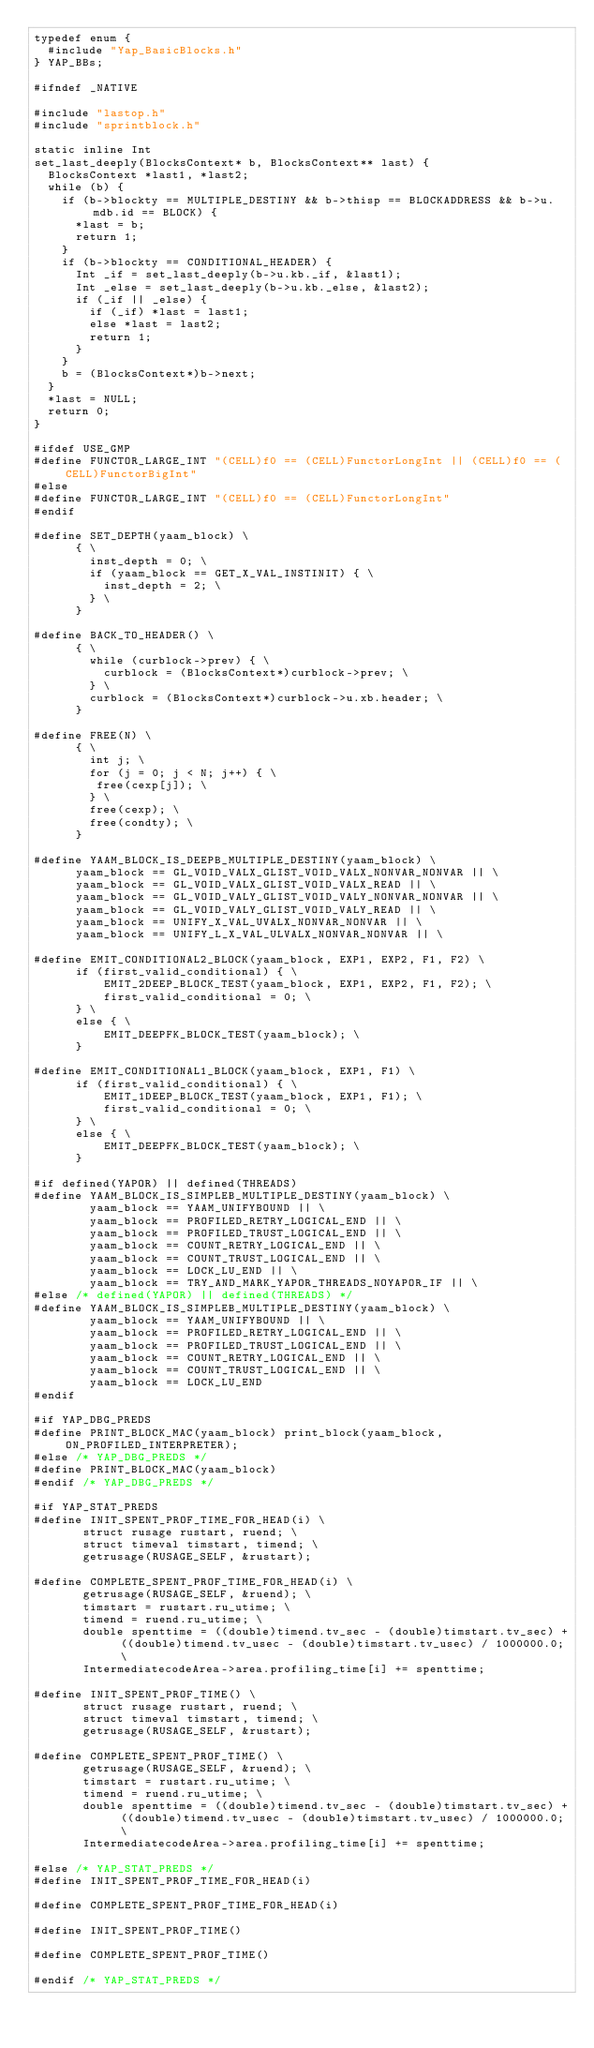<code> <loc_0><loc_0><loc_500><loc_500><_C++_>typedef enum {
  #include "Yap_BasicBlocks.h"
} YAP_BBs;

#ifndef _NATIVE

#include "lastop.h"
#include "sprintblock.h"

static inline Int
set_last_deeply(BlocksContext* b, BlocksContext** last) {
  BlocksContext *last1, *last2;
  while (b) {
    if (b->blockty == MULTIPLE_DESTINY && b->thisp == BLOCKADDRESS && b->u.mdb.id == BLOCK) {
      *last = b;
      return 1;
    }
    if (b->blockty == CONDITIONAL_HEADER) {
	  Int _if = set_last_deeply(b->u.kb._if, &last1);
	  Int _else = set_last_deeply(b->u.kb._else, &last2);
      if (_if || _else) {
		if (_if) *last = last1;
		else *last = last2;
	    return 1;
	  }
    }
    b = (BlocksContext*)b->next;
  }
  *last = NULL;
  return 0;
}

#ifdef USE_GMP
#define FUNCTOR_LARGE_INT "(CELL)f0 == (CELL)FunctorLongInt || (CELL)f0 == (CELL)FunctorBigInt"
#else
#define FUNCTOR_LARGE_INT "(CELL)f0 == (CELL)FunctorLongInt"
#endif

#define SET_DEPTH(yaam_block) \
      { \
	    inst_depth = 0; \
	    if (yaam_block == GET_X_VAL_INSTINIT) { \
	      inst_depth = 2; \
		} \
	  }

#define BACK_TO_HEADER() \
      { \
        while (curblock->prev) { \
          curblock = (BlocksContext*)curblock->prev; \
        } \
        curblock = (BlocksContext*)curblock->u.xb.header; \
      }
      
#define FREE(N) \
      { \
		int j; \
		for (j = 0; j < N; j++) { \
		 free(cexp[j]); \
		} \
		free(cexp); \
		free(condty); \
	  }

#define YAAM_BLOCK_IS_DEEPB_MULTIPLE_DESTINY(yaam_block) \
	  yaam_block == GL_VOID_VALX_GLIST_VOID_VALX_NONVAR_NONVAR || \
	  yaam_block == GL_VOID_VALX_GLIST_VOID_VALX_READ || \
	  yaam_block == GL_VOID_VALY_GLIST_VOID_VALY_NONVAR_NONVAR || \
	  yaam_block == GL_VOID_VALY_GLIST_VOID_VALY_READ || \
	  yaam_block == UNIFY_X_VAL_UVALX_NONVAR_NONVAR || \
	  yaam_block == UNIFY_L_X_VAL_ULVALX_NONVAR_NONVAR || \
	  
#define EMIT_CONDITIONAL2_BLOCK(yaam_block, EXP1, EXP2, F1, F2) \
	  if (first_valid_conditional) { \
	      EMIT_2DEEP_BLOCK_TEST(yaam_block, EXP1, EXP2, F1, F2); \
	      first_valid_conditional = 0; \
	  } \
	  else { \
	      EMIT_DEEPFK_BLOCK_TEST(yaam_block); \
	  }
	  
#define EMIT_CONDITIONAL1_BLOCK(yaam_block, EXP1, F1) \
	  if (first_valid_conditional) { \
	      EMIT_1DEEP_BLOCK_TEST(yaam_block, EXP1, F1); \
	      first_valid_conditional = 0; \
	  } \
	  else { \
	      EMIT_DEEPFK_BLOCK_TEST(yaam_block); \
	  }
      
#if defined(YAPOR) || defined(THREADS)
#define YAAM_BLOCK_IS_SIMPLEB_MULTIPLE_DESTINY(yaam_block) \
        yaam_block == YAAM_UNIFYBOUND || \
		yaam_block == PROFILED_RETRY_LOGICAL_END || \
		yaam_block == PROFILED_TRUST_LOGICAL_END || \
		yaam_block == COUNT_RETRY_LOGICAL_END || \
		yaam_block == COUNT_TRUST_LOGICAL_END || \
		yaam_block == LOCK_LU_END || \
		yaam_block == TRY_AND_MARK_YAPOR_THREADS_NOYAPOR_IF || \
#else /* defined(YAPOR) || defined(THREADS) */
#define YAAM_BLOCK_IS_SIMPLEB_MULTIPLE_DESTINY(yaam_block) \
        yaam_block == YAAM_UNIFYBOUND || \
		yaam_block == PROFILED_RETRY_LOGICAL_END || \
		yaam_block == PROFILED_TRUST_LOGICAL_END || \
		yaam_block == COUNT_RETRY_LOGICAL_END || \
		yaam_block == COUNT_TRUST_LOGICAL_END || \
		yaam_block == LOCK_LU_END
#endif

#if YAP_DBG_PREDS
#define PRINT_BLOCK_MAC(yaam_block) print_block(yaam_block, ON_PROFILED_INTERPRETER);
#else /* YAP_DBG_PREDS */
#define PRINT_BLOCK_MAC(yaam_block)
#endif /* YAP_DBG_PREDS */

#if YAP_STAT_PREDS
#define INIT_SPENT_PROF_TIME_FOR_HEAD(i) \
       struct rusage rustart, ruend; \
       struct timeval timstart, timend; \
       getrusage(RUSAGE_SELF, &rustart);

#define COMPLETE_SPENT_PROF_TIME_FOR_HEAD(i) \
       getrusage(RUSAGE_SELF, &ruend); \
       timstart = rustart.ru_utime; \
       timend = ruend.ru_utime; \
       double spenttime = ((double)timend.tv_sec - (double)timstart.tv_sec) + ((double)timend.tv_usec - (double)timstart.tv_usec) / 1000000.0; \
       IntermediatecodeArea->area.profiling_time[i] += spenttime;

#define INIT_SPENT_PROF_TIME() \
       struct rusage rustart, ruend; \
       struct timeval timstart, timend; \
       getrusage(RUSAGE_SELF, &rustart);

#define COMPLETE_SPENT_PROF_TIME() \
       getrusage(RUSAGE_SELF, &ruend); \
       timstart = rustart.ru_utime; \
       timend = ruend.ru_utime; \
       double spenttime = ((double)timend.tv_sec - (double)timstart.tv_sec) + ((double)timend.tv_usec - (double)timstart.tv_usec) / 1000000.0; \
       IntermediatecodeArea->area.profiling_time[i] += spenttime;

#else /* YAP_STAT_PREDS */
#define INIT_SPENT_PROF_TIME_FOR_HEAD(i)

#define COMPLETE_SPENT_PROF_TIME_FOR_HEAD(i)

#define INIT_SPENT_PROF_TIME()

#define COMPLETE_SPENT_PROF_TIME()

#endif /* YAP_STAT_PREDS */
</code> 